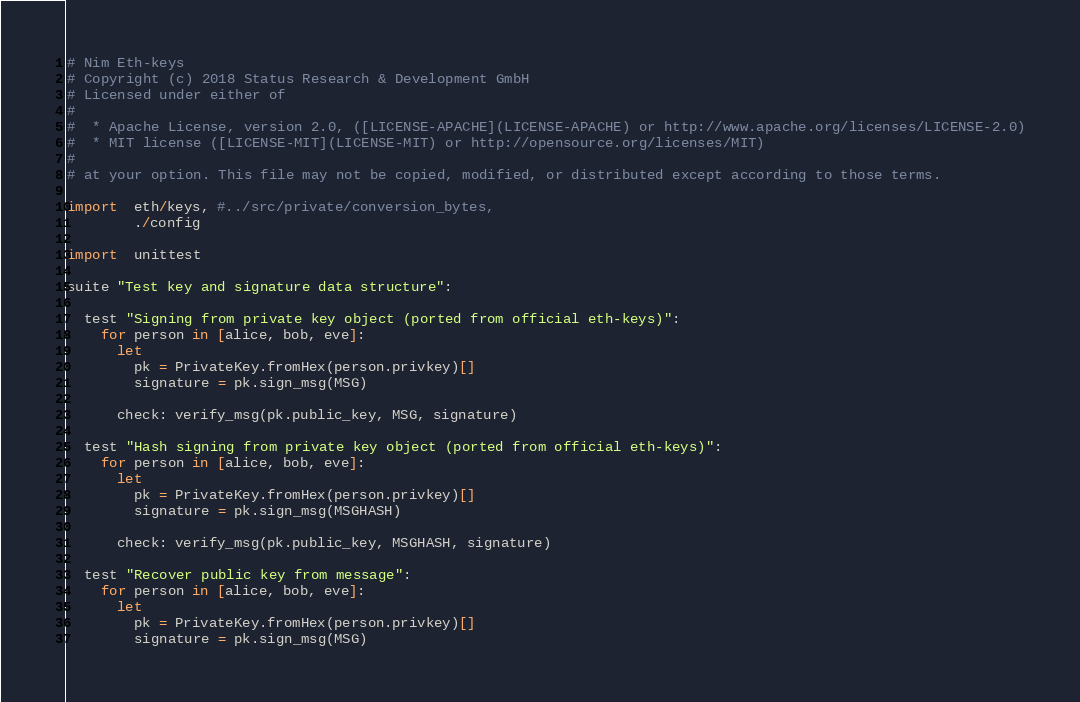<code> <loc_0><loc_0><loc_500><loc_500><_Nim_># Nim Eth-keys
# Copyright (c) 2018 Status Research & Development GmbH
# Licensed under either of
#
#  * Apache License, version 2.0, ([LICENSE-APACHE](LICENSE-APACHE) or http://www.apache.org/licenses/LICENSE-2.0)
#  * MIT license ([LICENSE-MIT](LICENSE-MIT) or http://opensource.org/licenses/MIT)
#
# at your option. This file may not be copied, modified, or distributed except according to those terms.

import  eth/keys, #../src/private/conversion_bytes,
        ./config

import  unittest

suite "Test key and signature data structure":

  test "Signing from private key object (ported from official eth-keys)":
    for person in [alice, bob, eve]:
      let
        pk = PrivateKey.fromHex(person.privkey)[]
        signature = pk.sign_msg(MSG)

      check: verify_msg(pk.public_key, MSG, signature)

  test "Hash signing from private key object (ported from official eth-keys)":
    for person in [alice, bob, eve]:
      let
        pk = PrivateKey.fromHex(person.privkey)[]
        signature = pk.sign_msg(MSGHASH)

      check: verify_msg(pk.public_key, MSGHASH, signature)

  test "Recover public key from message":
    for person in [alice, bob, eve]:
      let
        pk = PrivateKey.fromHex(person.privkey)[]
        signature = pk.sign_msg(MSG)
</code> 